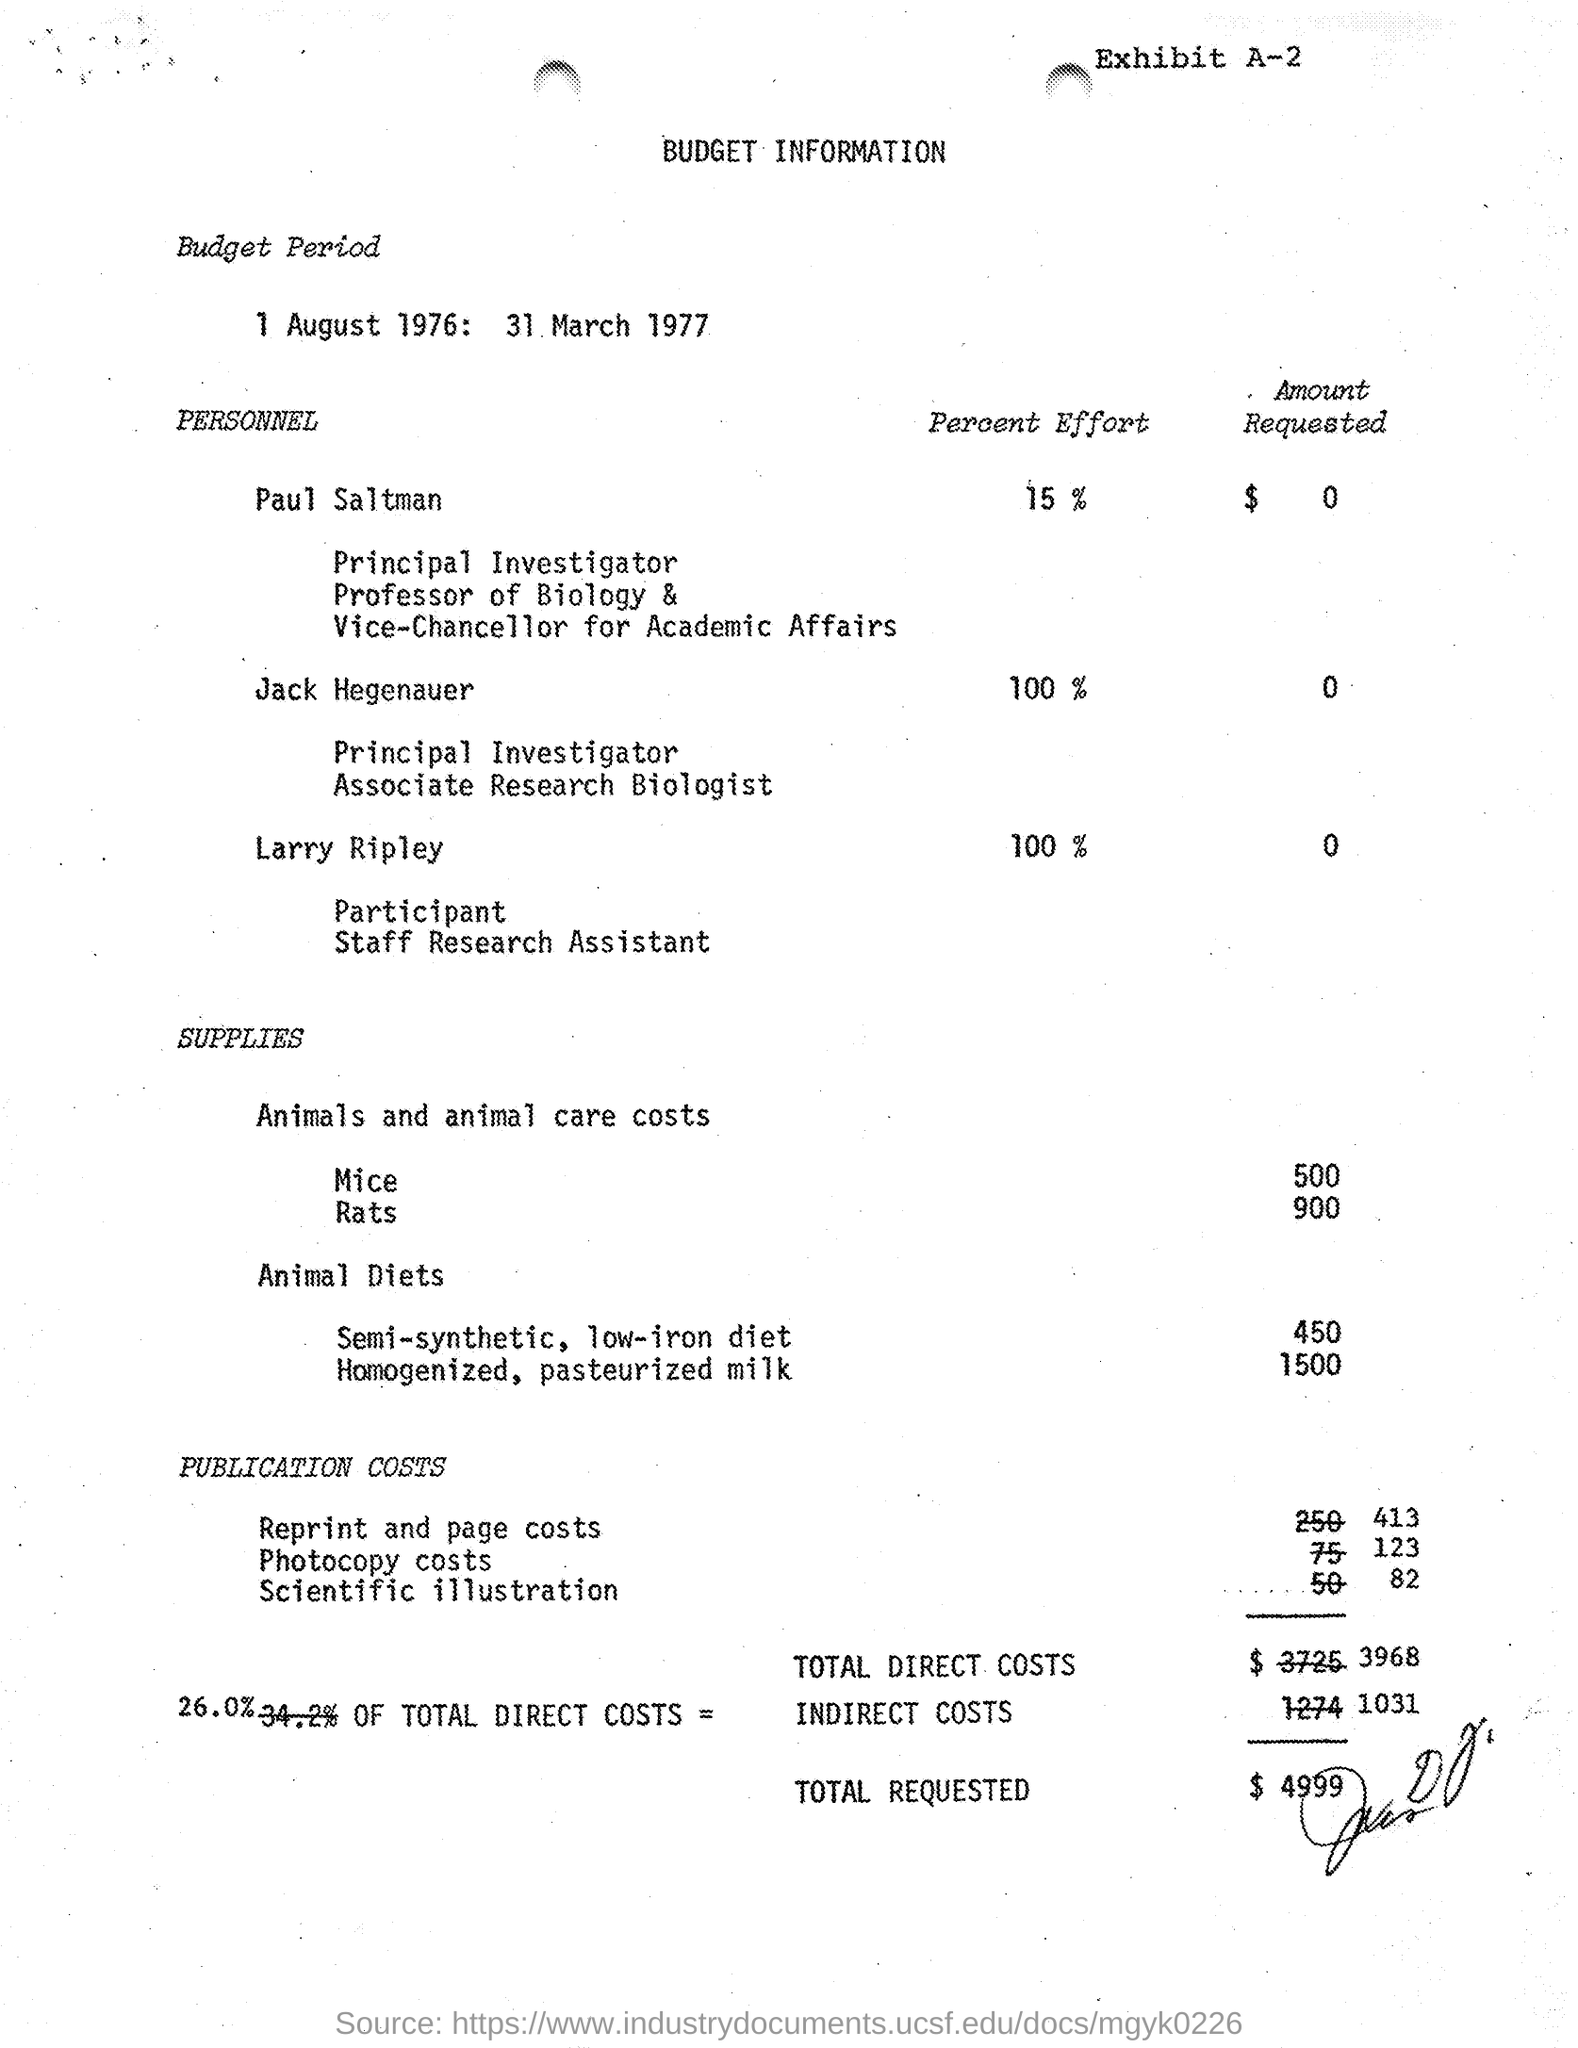What is the total requested budget as given in the document?
Offer a terse response. $4,999. What is the Budget for total direct costs as per the document?
Your answer should be very brief. $3968. What Percent effort is given by Jack Hegenauer to the project?
Make the answer very short. 100%. What is the Budget Period mentioned in the document?
Ensure brevity in your answer.  1 August 1976: 31 March 1977. 